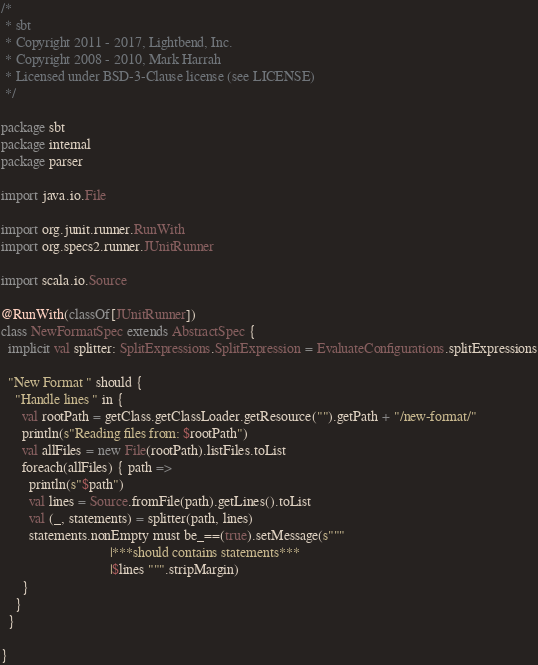<code> <loc_0><loc_0><loc_500><loc_500><_Scala_>/*
 * sbt
 * Copyright 2011 - 2017, Lightbend, Inc.
 * Copyright 2008 - 2010, Mark Harrah
 * Licensed under BSD-3-Clause license (see LICENSE)
 */

package sbt
package internal
package parser

import java.io.File

import org.junit.runner.RunWith
import org.specs2.runner.JUnitRunner

import scala.io.Source

@RunWith(classOf[JUnitRunner])
class NewFormatSpec extends AbstractSpec {
  implicit val splitter: SplitExpressions.SplitExpression = EvaluateConfigurations.splitExpressions

  "New Format " should {
    "Handle lines " in {
      val rootPath = getClass.getClassLoader.getResource("").getPath + "/new-format/"
      println(s"Reading files from: $rootPath")
      val allFiles = new File(rootPath).listFiles.toList
      foreach(allFiles) { path =>
        println(s"$path")
        val lines = Source.fromFile(path).getLines().toList
        val (_, statements) = splitter(path, lines)
        statements.nonEmpty must be_==(true).setMessage(s"""
                               |***should contains statements***
                               |$lines """.stripMargin)
      }
    }
  }

}
</code> 